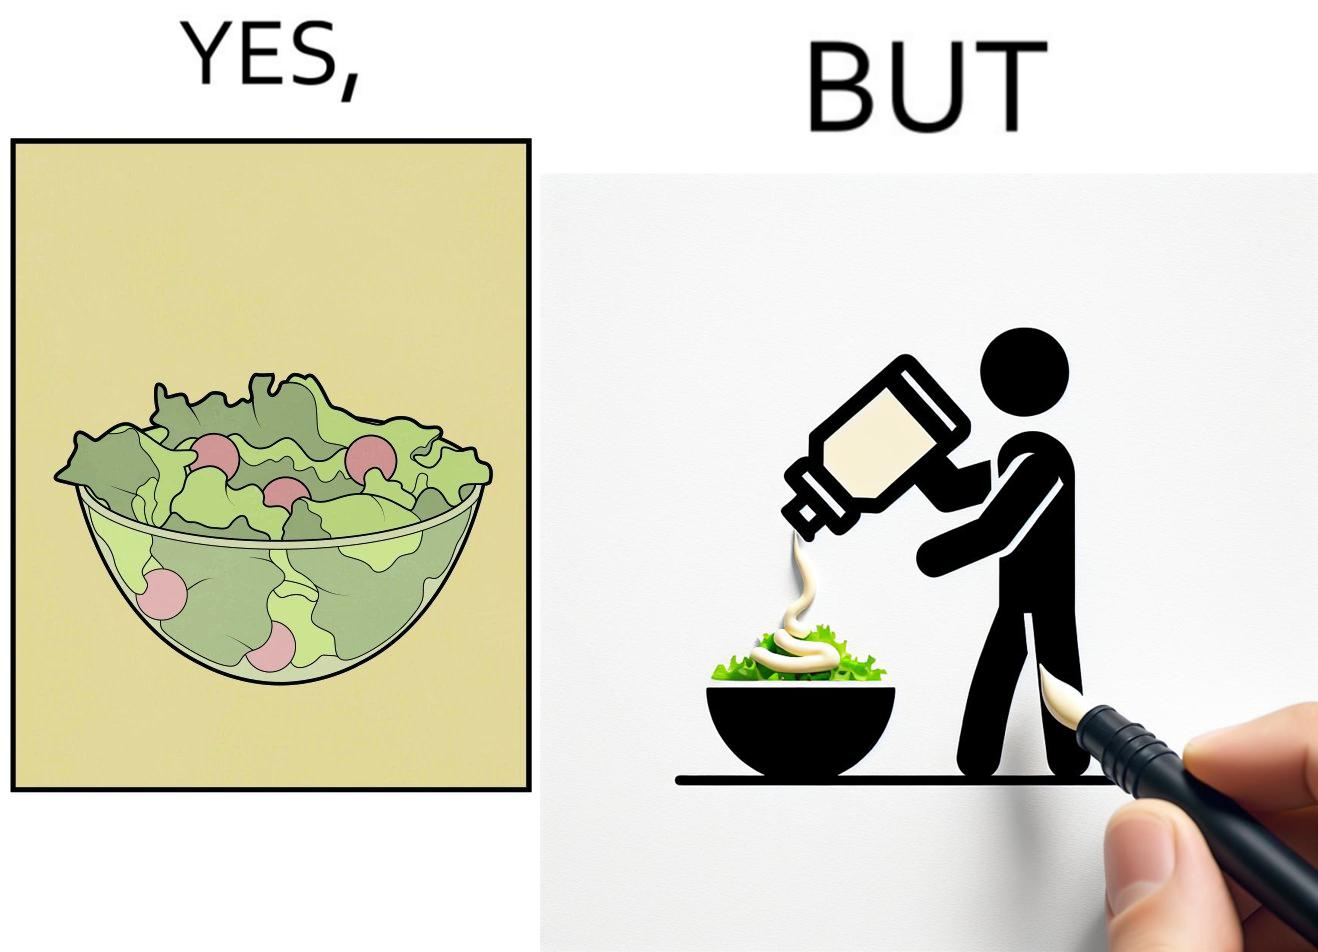Compare the left and right sides of this image. In the left part of the image: salad in a bowl In the right part of the image: pouring mayonnaise sauce on salad in a bowl 